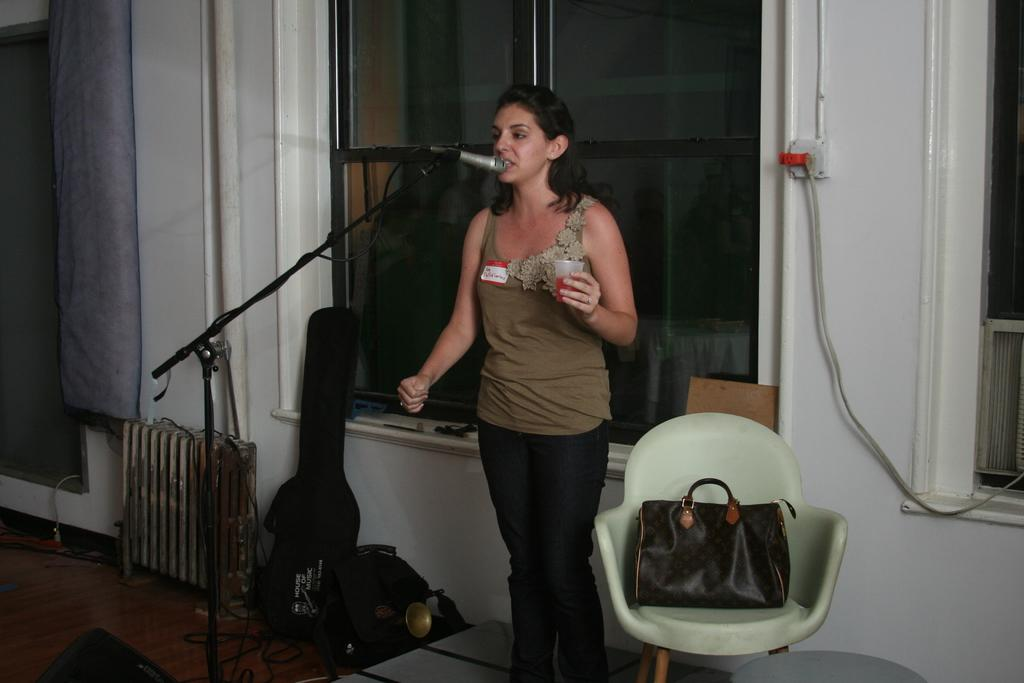What is the woman in the image doing? The woman is singing in the image. What object is the woman holding? The woman is holding a glass in the image. What device is used for amplifying her voice? There is a microphone in the image. What piece of furniture is present in the image? There is a chair in the image. What is placed on the chair? A bag is present on the chair. What can be found on the floor in the image? There are cables and bags on the floor in the image. What is visible in the background of the image? There is a window in the image. Can you hear the fairies laughing in the image? There are no fairies or laughter present in the image; it features a woman singing with a microphone and other objects. 